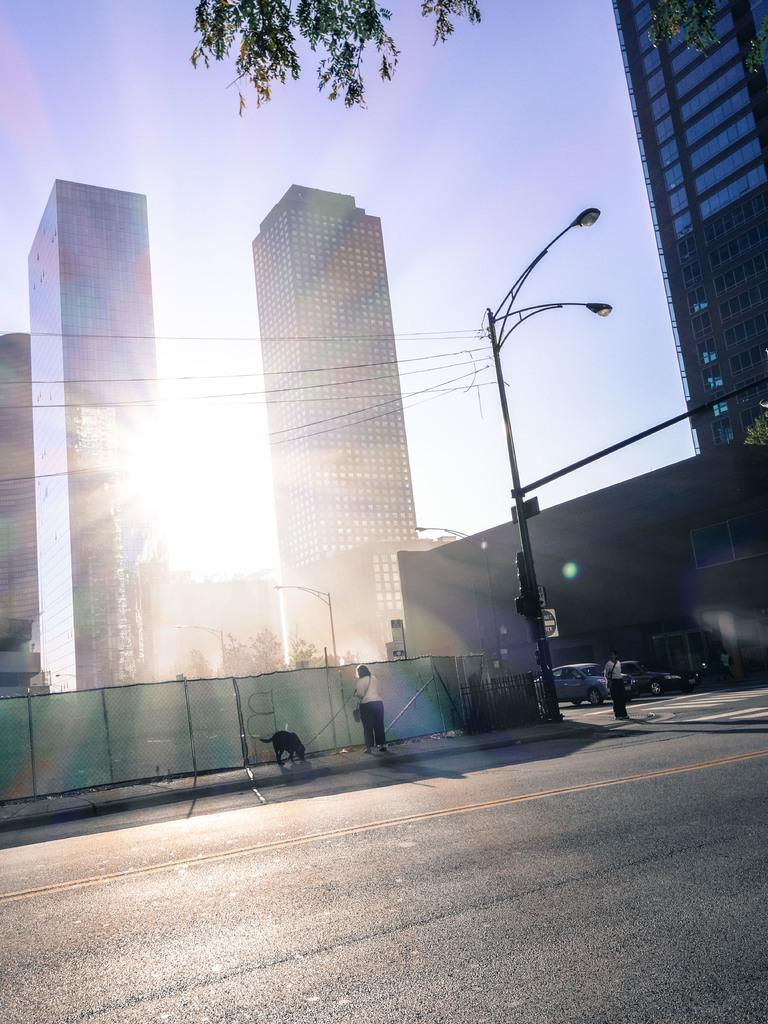What type of structures can be seen in the image? There are buildings in the image. What objects are present alongside the buildings? There are poles and lights in the image. What type of vegetation is visible in the image? There are trees in the image. What is happening on the road in the image? There are vehicles and persons on the road in the image. Can you identify any animals in the image? Yes, this is a dog in the image. What can be seen in the background of the image? The sky is visible in the background of the image. Can you tell me how many times the dog sneezes in the image? There is no indication of the dog sneezing in the image; it is simply present. What type of pain is the person on the road experiencing in the image? There is no indication of any person experiencing pain in the image. 